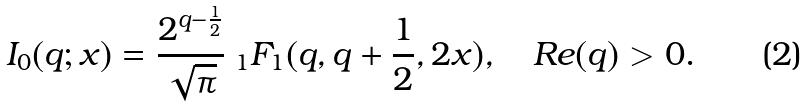Convert formula to latex. <formula><loc_0><loc_0><loc_500><loc_500>I _ { 0 } ( q ; x ) = \frac { 2 ^ { q - \frac { 1 } { 2 } } } { \sqrt { \pi } } \ { _ { 1 } F _ { 1 } } ( q , q + \frac { 1 } { 2 } , 2 x ) , \quad R e ( q ) > 0 .</formula> 